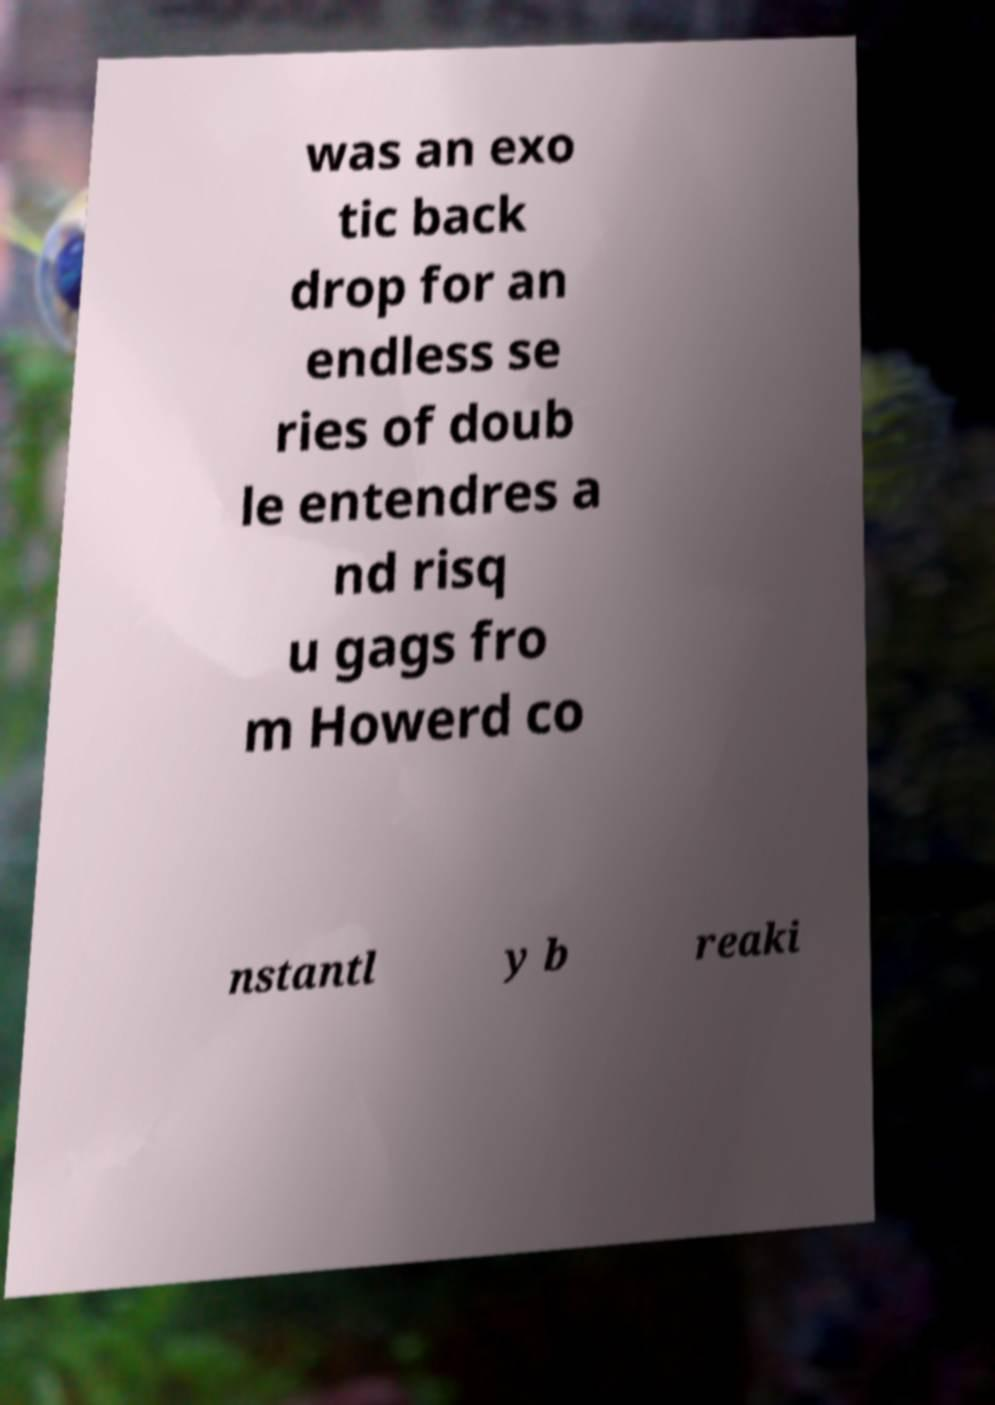Could you extract and type out the text from this image? was an exo tic back drop for an endless se ries of doub le entendres a nd risq u gags fro m Howerd co nstantl y b reaki 